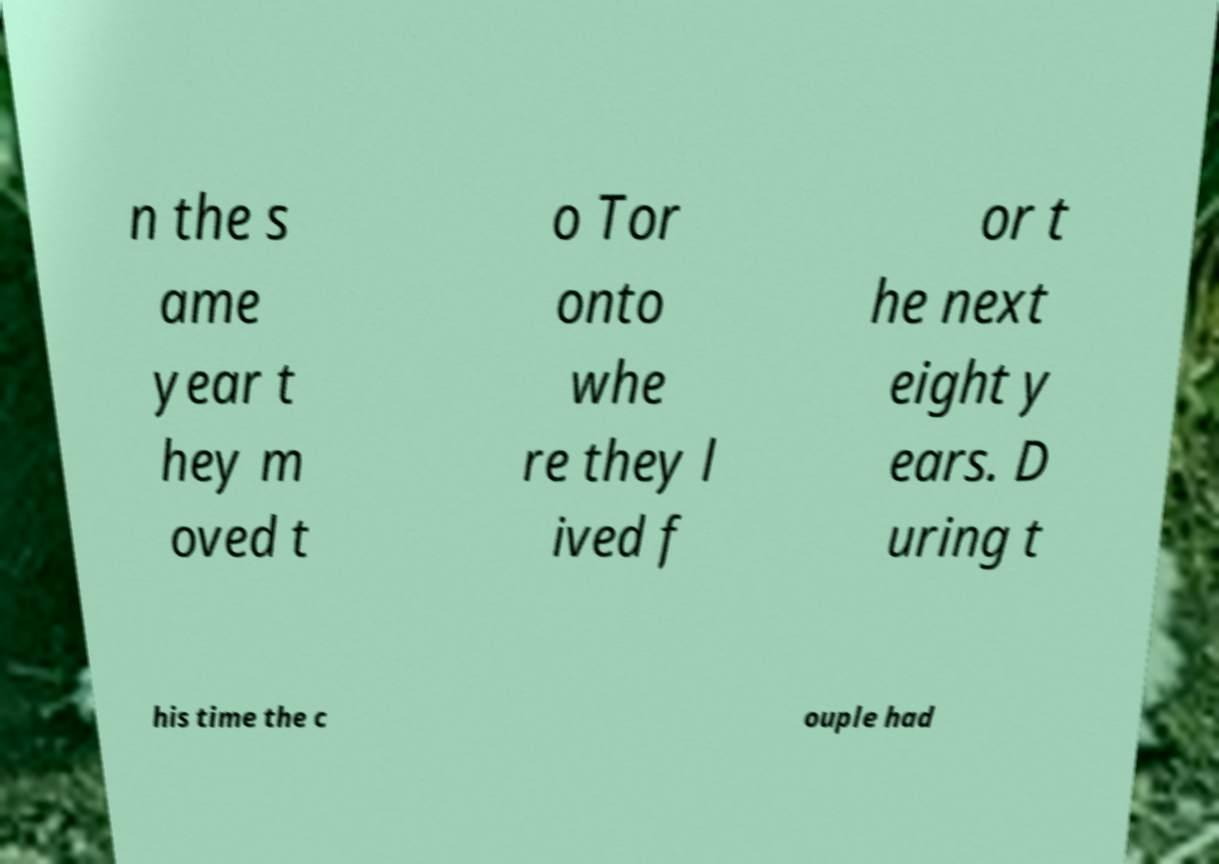There's text embedded in this image that I need extracted. Can you transcribe it verbatim? n the s ame year t hey m oved t o Tor onto whe re they l ived f or t he next eight y ears. D uring t his time the c ouple had 